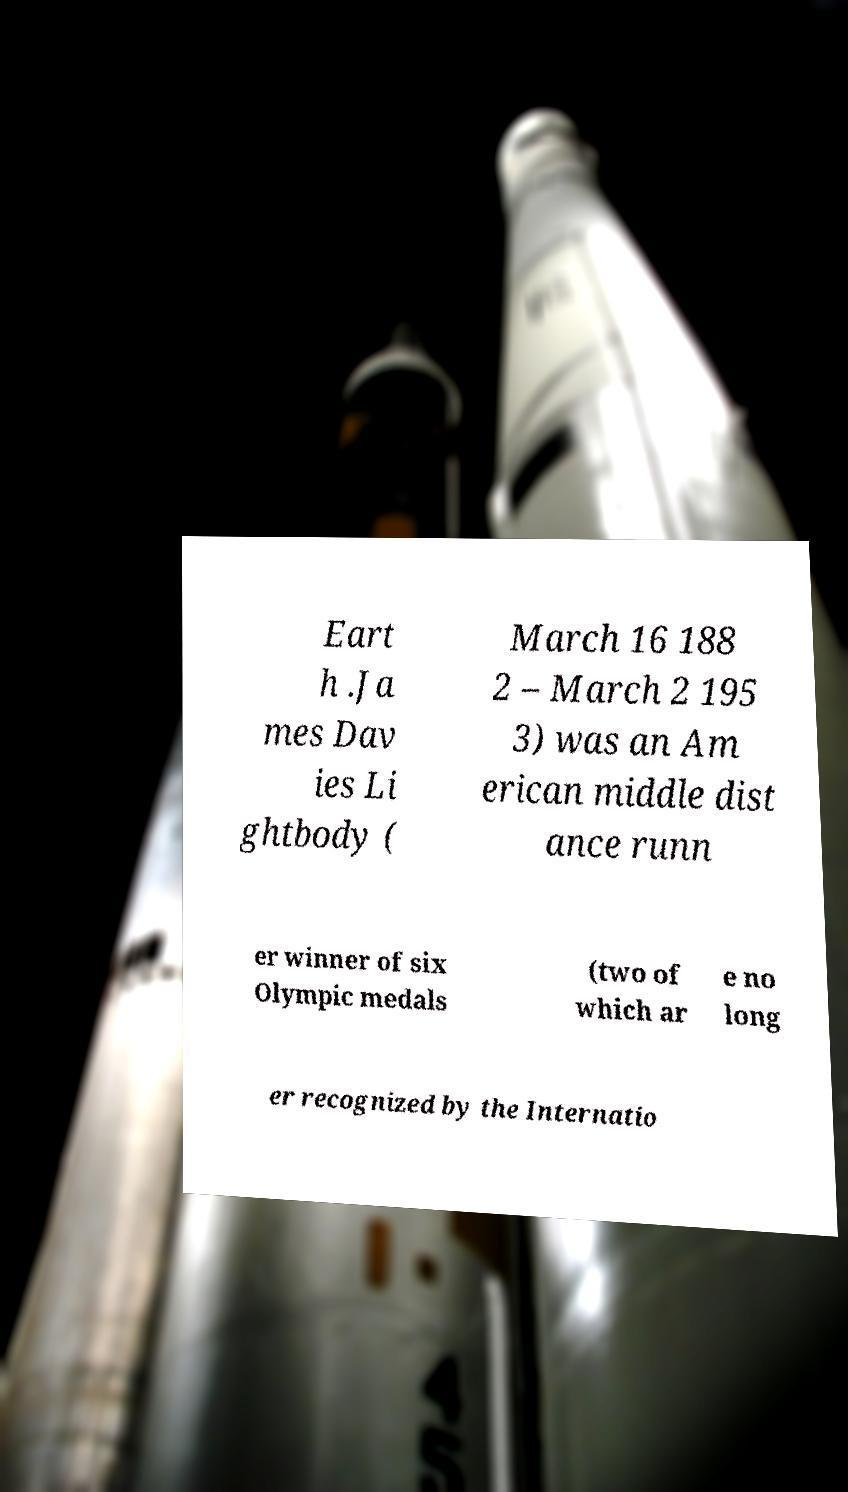Can you read and provide the text displayed in the image?This photo seems to have some interesting text. Can you extract and type it out for me? Eart h .Ja mes Dav ies Li ghtbody ( March 16 188 2 – March 2 195 3) was an Am erican middle dist ance runn er winner of six Olympic medals (two of which ar e no long er recognized by the Internatio 